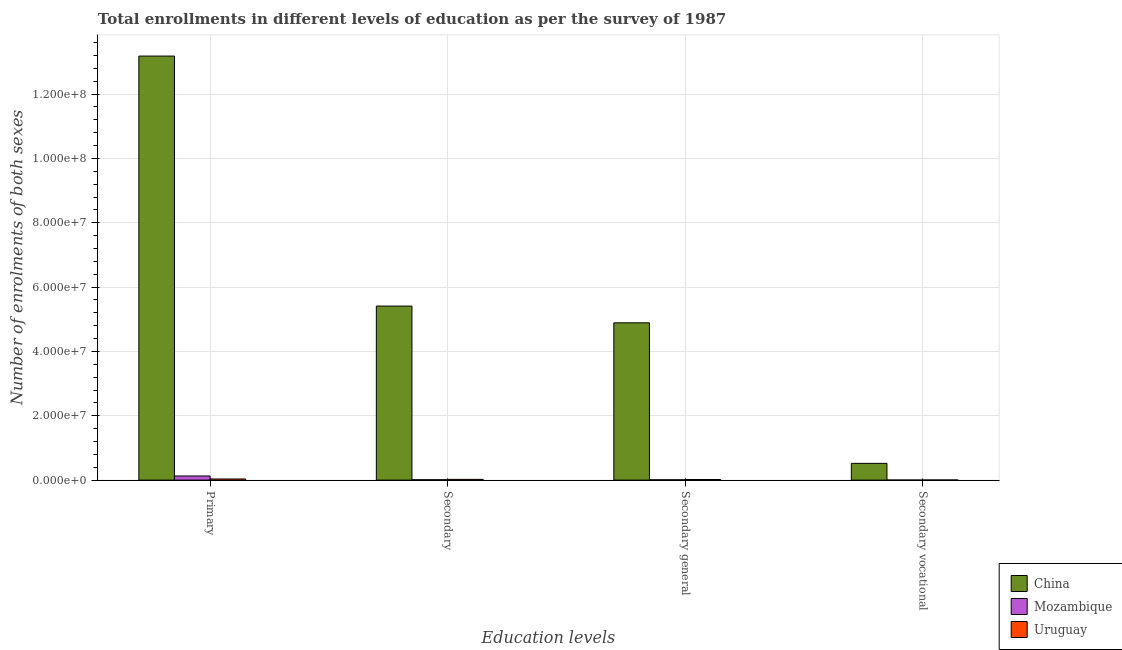Are the number of bars on each tick of the X-axis equal?
Your answer should be compact. Yes. What is the label of the 2nd group of bars from the left?
Offer a very short reply. Secondary. What is the number of enrolments in secondary education in Uruguay?
Give a very brief answer. 2.29e+05. Across all countries, what is the maximum number of enrolments in secondary education?
Provide a succinct answer. 5.41e+07. Across all countries, what is the minimum number of enrolments in secondary education?
Keep it short and to the point. 1.17e+05. In which country was the number of enrolments in primary education minimum?
Provide a short and direct response. Uruguay. What is the total number of enrolments in secondary vocational education in the graph?
Offer a very short reply. 5.26e+06. What is the difference between the number of enrolments in secondary education in China and that in Uruguay?
Your response must be concise. 5.39e+07. What is the difference between the number of enrolments in secondary general education in China and the number of enrolments in secondary vocational education in Mozambique?
Your response must be concise. 4.89e+07. What is the average number of enrolments in primary education per country?
Offer a very short reply. 4.45e+07. What is the difference between the number of enrolments in primary education and number of enrolments in secondary vocational education in Uruguay?
Your answer should be compact. 3.17e+05. What is the ratio of the number of enrolments in secondary general education in Uruguay to that in China?
Provide a succinct answer. 0. Is the number of enrolments in secondary general education in Mozambique less than that in China?
Ensure brevity in your answer.  Yes. Is the difference between the number of enrolments in secondary general education in Mozambique and China greater than the difference between the number of enrolments in secondary education in Mozambique and China?
Ensure brevity in your answer.  Yes. What is the difference between the highest and the second highest number of enrolments in secondary general education?
Provide a succinct answer. 4.87e+07. What is the difference between the highest and the lowest number of enrolments in primary education?
Your response must be concise. 1.31e+08. In how many countries, is the number of enrolments in secondary general education greater than the average number of enrolments in secondary general education taken over all countries?
Make the answer very short. 1. Is it the case that in every country, the sum of the number of enrolments in secondary education and number of enrolments in primary education is greater than the sum of number of enrolments in secondary vocational education and number of enrolments in secondary general education?
Your response must be concise. No. What does the 2nd bar from the left in Secondary represents?
Your response must be concise. Mozambique. What does the 1st bar from the right in Secondary general represents?
Your response must be concise. Uruguay. What is the difference between two consecutive major ticks on the Y-axis?
Your answer should be compact. 2.00e+07. Where does the legend appear in the graph?
Your answer should be very brief. Bottom right. How many legend labels are there?
Your response must be concise. 3. How are the legend labels stacked?
Keep it short and to the point. Vertical. What is the title of the graph?
Your response must be concise. Total enrollments in different levels of education as per the survey of 1987. Does "Rwanda" appear as one of the legend labels in the graph?
Make the answer very short. No. What is the label or title of the X-axis?
Your answer should be compact. Education levels. What is the label or title of the Y-axis?
Your answer should be compact. Number of enrolments of both sexes. What is the Number of enrolments of both sexes of China in Primary?
Your response must be concise. 1.32e+08. What is the Number of enrolments of both sexes of Mozambique in Primary?
Ensure brevity in your answer.  1.29e+06. What is the Number of enrolments of both sexes in Uruguay in Primary?
Give a very brief answer. 3.54e+05. What is the Number of enrolments of both sexes of China in Secondary?
Your answer should be very brief. 5.41e+07. What is the Number of enrolments of both sexes in Mozambique in Secondary?
Offer a very short reply. 1.17e+05. What is the Number of enrolments of both sexes of Uruguay in Secondary?
Your answer should be very brief. 2.29e+05. What is the Number of enrolments of both sexes in China in Secondary general?
Make the answer very short. 4.89e+07. What is the Number of enrolments of both sexes in Mozambique in Secondary general?
Offer a terse response. 1.03e+05. What is the Number of enrolments of both sexes in Uruguay in Secondary general?
Your response must be concise. 1.92e+05. What is the Number of enrolments of both sexes of China in Secondary vocational?
Provide a succinct answer. 5.21e+06. What is the Number of enrolments of both sexes of Mozambique in Secondary vocational?
Your response must be concise. 1.36e+04. What is the Number of enrolments of both sexes in Uruguay in Secondary vocational?
Your answer should be very brief. 3.69e+04. Across all Education levels, what is the maximum Number of enrolments of both sexes in China?
Ensure brevity in your answer.  1.32e+08. Across all Education levels, what is the maximum Number of enrolments of both sexes of Mozambique?
Your response must be concise. 1.29e+06. Across all Education levels, what is the maximum Number of enrolments of both sexes in Uruguay?
Keep it short and to the point. 3.54e+05. Across all Education levels, what is the minimum Number of enrolments of both sexes of China?
Offer a terse response. 5.21e+06. Across all Education levels, what is the minimum Number of enrolments of both sexes in Mozambique?
Offer a terse response. 1.36e+04. Across all Education levels, what is the minimum Number of enrolments of both sexes in Uruguay?
Offer a very short reply. 3.69e+04. What is the total Number of enrolments of both sexes in China in the graph?
Make the answer very short. 2.40e+08. What is the total Number of enrolments of both sexes of Mozambique in the graph?
Provide a short and direct response. 1.52e+06. What is the total Number of enrolments of both sexes in Uruguay in the graph?
Your answer should be very brief. 8.12e+05. What is the difference between the Number of enrolments of both sexes of China in Primary and that in Secondary?
Ensure brevity in your answer.  7.77e+07. What is the difference between the Number of enrolments of both sexes of Mozambique in Primary and that in Secondary?
Ensure brevity in your answer.  1.17e+06. What is the difference between the Number of enrolments of both sexes of Uruguay in Primary and that in Secondary?
Offer a terse response. 1.25e+05. What is the difference between the Number of enrolments of both sexes of China in Primary and that in Secondary general?
Your response must be concise. 8.29e+07. What is the difference between the Number of enrolments of both sexes in Mozambique in Primary and that in Secondary general?
Your response must be concise. 1.18e+06. What is the difference between the Number of enrolments of both sexes in Uruguay in Primary and that in Secondary general?
Your response must be concise. 1.62e+05. What is the difference between the Number of enrolments of both sexes of China in Primary and that in Secondary vocational?
Provide a short and direct response. 1.27e+08. What is the difference between the Number of enrolments of both sexes in Mozambique in Primary and that in Secondary vocational?
Provide a short and direct response. 1.27e+06. What is the difference between the Number of enrolments of both sexes in Uruguay in Primary and that in Secondary vocational?
Provide a short and direct response. 3.17e+05. What is the difference between the Number of enrolments of both sexes in China in Secondary and that in Secondary general?
Keep it short and to the point. 5.21e+06. What is the difference between the Number of enrolments of both sexes of Mozambique in Secondary and that in Secondary general?
Provide a succinct answer. 1.36e+04. What is the difference between the Number of enrolments of both sexes in Uruguay in Secondary and that in Secondary general?
Your response must be concise. 3.69e+04. What is the difference between the Number of enrolments of both sexes in China in Secondary and that in Secondary vocational?
Offer a terse response. 4.89e+07. What is the difference between the Number of enrolments of both sexes in Mozambique in Secondary and that in Secondary vocational?
Keep it short and to the point. 1.03e+05. What is the difference between the Number of enrolments of both sexes in Uruguay in Secondary and that in Secondary vocational?
Make the answer very short. 1.92e+05. What is the difference between the Number of enrolments of both sexes of China in Secondary general and that in Secondary vocational?
Your answer should be very brief. 4.37e+07. What is the difference between the Number of enrolments of both sexes of Mozambique in Secondary general and that in Secondary vocational?
Your answer should be compact. 8.97e+04. What is the difference between the Number of enrolments of both sexes of Uruguay in Secondary general and that in Secondary vocational?
Provide a short and direct response. 1.55e+05. What is the difference between the Number of enrolments of both sexes in China in Primary and the Number of enrolments of both sexes in Mozambique in Secondary?
Keep it short and to the point. 1.32e+08. What is the difference between the Number of enrolments of both sexes in China in Primary and the Number of enrolments of both sexes in Uruguay in Secondary?
Offer a very short reply. 1.32e+08. What is the difference between the Number of enrolments of both sexes in Mozambique in Primary and the Number of enrolments of both sexes in Uruguay in Secondary?
Your response must be concise. 1.06e+06. What is the difference between the Number of enrolments of both sexes in China in Primary and the Number of enrolments of both sexes in Mozambique in Secondary general?
Offer a very short reply. 1.32e+08. What is the difference between the Number of enrolments of both sexes in China in Primary and the Number of enrolments of both sexes in Uruguay in Secondary general?
Offer a very short reply. 1.32e+08. What is the difference between the Number of enrolments of both sexes in Mozambique in Primary and the Number of enrolments of both sexes in Uruguay in Secondary general?
Provide a succinct answer. 1.10e+06. What is the difference between the Number of enrolments of both sexes in China in Primary and the Number of enrolments of both sexes in Mozambique in Secondary vocational?
Provide a short and direct response. 1.32e+08. What is the difference between the Number of enrolments of both sexes in China in Primary and the Number of enrolments of both sexes in Uruguay in Secondary vocational?
Your answer should be compact. 1.32e+08. What is the difference between the Number of enrolments of both sexes in Mozambique in Primary and the Number of enrolments of both sexes in Uruguay in Secondary vocational?
Your answer should be very brief. 1.25e+06. What is the difference between the Number of enrolments of both sexes of China in Secondary and the Number of enrolments of both sexes of Mozambique in Secondary general?
Offer a terse response. 5.40e+07. What is the difference between the Number of enrolments of both sexes in China in Secondary and the Number of enrolments of both sexes in Uruguay in Secondary general?
Your response must be concise. 5.39e+07. What is the difference between the Number of enrolments of both sexes of Mozambique in Secondary and the Number of enrolments of both sexes of Uruguay in Secondary general?
Offer a terse response. -7.52e+04. What is the difference between the Number of enrolments of both sexes in China in Secondary and the Number of enrolments of both sexes in Mozambique in Secondary vocational?
Offer a very short reply. 5.41e+07. What is the difference between the Number of enrolments of both sexes of China in Secondary and the Number of enrolments of both sexes of Uruguay in Secondary vocational?
Your answer should be compact. 5.41e+07. What is the difference between the Number of enrolments of both sexes of Mozambique in Secondary and the Number of enrolments of both sexes of Uruguay in Secondary vocational?
Your answer should be compact. 8.00e+04. What is the difference between the Number of enrolments of both sexes of China in Secondary general and the Number of enrolments of both sexes of Mozambique in Secondary vocational?
Provide a succinct answer. 4.89e+07. What is the difference between the Number of enrolments of both sexes in China in Secondary general and the Number of enrolments of both sexes in Uruguay in Secondary vocational?
Provide a short and direct response. 4.89e+07. What is the difference between the Number of enrolments of both sexes of Mozambique in Secondary general and the Number of enrolments of both sexes of Uruguay in Secondary vocational?
Give a very brief answer. 6.64e+04. What is the average Number of enrolments of both sexes of China per Education levels?
Your answer should be compact. 6.00e+07. What is the average Number of enrolments of both sexes of Mozambique per Education levels?
Make the answer very short. 3.80e+05. What is the average Number of enrolments of both sexes of Uruguay per Education levels?
Your response must be concise. 2.03e+05. What is the difference between the Number of enrolments of both sexes in China and Number of enrolments of both sexes in Mozambique in Primary?
Offer a terse response. 1.31e+08. What is the difference between the Number of enrolments of both sexes of China and Number of enrolments of both sexes of Uruguay in Primary?
Ensure brevity in your answer.  1.31e+08. What is the difference between the Number of enrolments of both sexes of Mozambique and Number of enrolments of both sexes of Uruguay in Primary?
Offer a very short reply. 9.34e+05. What is the difference between the Number of enrolments of both sexes of China and Number of enrolments of both sexes of Mozambique in Secondary?
Offer a terse response. 5.40e+07. What is the difference between the Number of enrolments of both sexes of China and Number of enrolments of both sexes of Uruguay in Secondary?
Offer a very short reply. 5.39e+07. What is the difference between the Number of enrolments of both sexes in Mozambique and Number of enrolments of both sexes in Uruguay in Secondary?
Your answer should be very brief. -1.12e+05. What is the difference between the Number of enrolments of both sexes of China and Number of enrolments of both sexes of Mozambique in Secondary general?
Your answer should be very brief. 4.88e+07. What is the difference between the Number of enrolments of both sexes in China and Number of enrolments of both sexes in Uruguay in Secondary general?
Ensure brevity in your answer.  4.87e+07. What is the difference between the Number of enrolments of both sexes of Mozambique and Number of enrolments of both sexes of Uruguay in Secondary general?
Your answer should be very brief. -8.88e+04. What is the difference between the Number of enrolments of both sexes in China and Number of enrolments of both sexes in Mozambique in Secondary vocational?
Your answer should be compact. 5.20e+06. What is the difference between the Number of enrolments of both sexes in China and Number of enrolments of both sexes in Uruguay in Secondary vocational?
Offer a very short reply. 5.17e+06. What is the difference between the Number of enrolments of both sexes of Mozambique and Number of enrolments of both sexes of Uruguay in Secondary vocational?
Your answer should be compact. -2.33e+04. What is the ratio of the Number of enrolments of both sexes in China in Primary to that in Secondary?
Provide a short and direct response. 2.44. What is the ratio of the Number of enrolments of both sexes in Mozambique in Primary to that in Secondary?
Your answer should be very brief. 11.01. What is the ratio of the Number of enrolments of both sexes of Uruguay in Primary to that in Secondary?
Offer a terse response. 1.55. What is the ratio of the Number of enrolments of both sexes of China in Primary to that in Secondary general?
Offer a very short reply. 2.7. What is the ratio of the Number of enrolments of both sexes in Mozambique in Primary to that in Secondary general?
Provide a short and direct response. 12.46. What is the ratio of the Number of enrolments of both sexes in Uruguay in Primary to that in Secondary general?
Your answer should be very brief. 1.84. What is the ratio of the Number of enrolments of both sexes in China in Primary to that in Secondary vocational?
Offer a terse response. 25.31. What is the ratio of the Number of enrolments of both sexes of Mozambique in Primary to that in Secondary vocational?
Your answer should be very brief. 94.64. What is the ratio of the Number of enrolments of both sexes of Uruguay in Primary to that in Secondary vocational?
Keep it short and to the point. 9.59. What is the ratio of the Number of enrolments of both sexes in China in Secondary to that in Secondary general?
Keep it short and to the point. 1.11. What is the ratio of the Number of enrolments of both sexes of Mozambique in Secondary to that in Secondary general?
Your answer should be compact. 1.13. What is the ratio of the Number of enrolments of both sexes of Uruguay in Secondary to that in Secondary general?
Your response must be concise. 1.19. What is the ratio of the Number of enrolments of both sexes in China in Secondary to that in Secondary vocational?
Offer a terse response. 10.39. What is the ratio of the Number of enrolments of both sexes in Mozambique in Secondary to that in Secondary vocational?
Make the answer very short. 8.59. What is the ratio of the Number of enrolments of both sexes in Uruguay in Secondary to that in Secondary vocational?
Provide a short and direct response. 6.2. What is the ratio of the Number of enrolments of both sexes in China in Secondary general to that in Secondary vocational?
Your answer should be compact. 9.39. What is the ratio of the Number of enrolments of both sexes in Mozambique in Secondary general to that in Secondary vocational?
Your answer should be very brief. 7.59. What is the ratio of the Number of enrolments of both sexes in Uruguay in Secondary general to that in Secondary vocational?
Your answer should be compact. 5.2. What is the difference between the highest and the second highest Number of enrolments of both sexes in China?
Keep it short and to the point. 7.77e+07. What is the difference between the highest and the second highest Number of enrolments of both sexes of Mozambique?
Provide a succinct answer. 1.17e+06. What is the difference between the highest and the second highest Number of enrolments of both sexes in Uruguay?
Ensure brevity in your answer.  1.25e+05. What is the difference between the highest and the lowest Number of enrolments of both sexes in China?
Your answer should be very brief. 1.27e+08. What is the difference between the highest and the lowest Number of enrolments of both sexes of Mozambique?
Offer a very short reply. 1.27e+06. What is the difference between the highest and the lowest Number of enrolments of both sexes in Uruguay?
Offer a very short reply. 3.17e+05. 